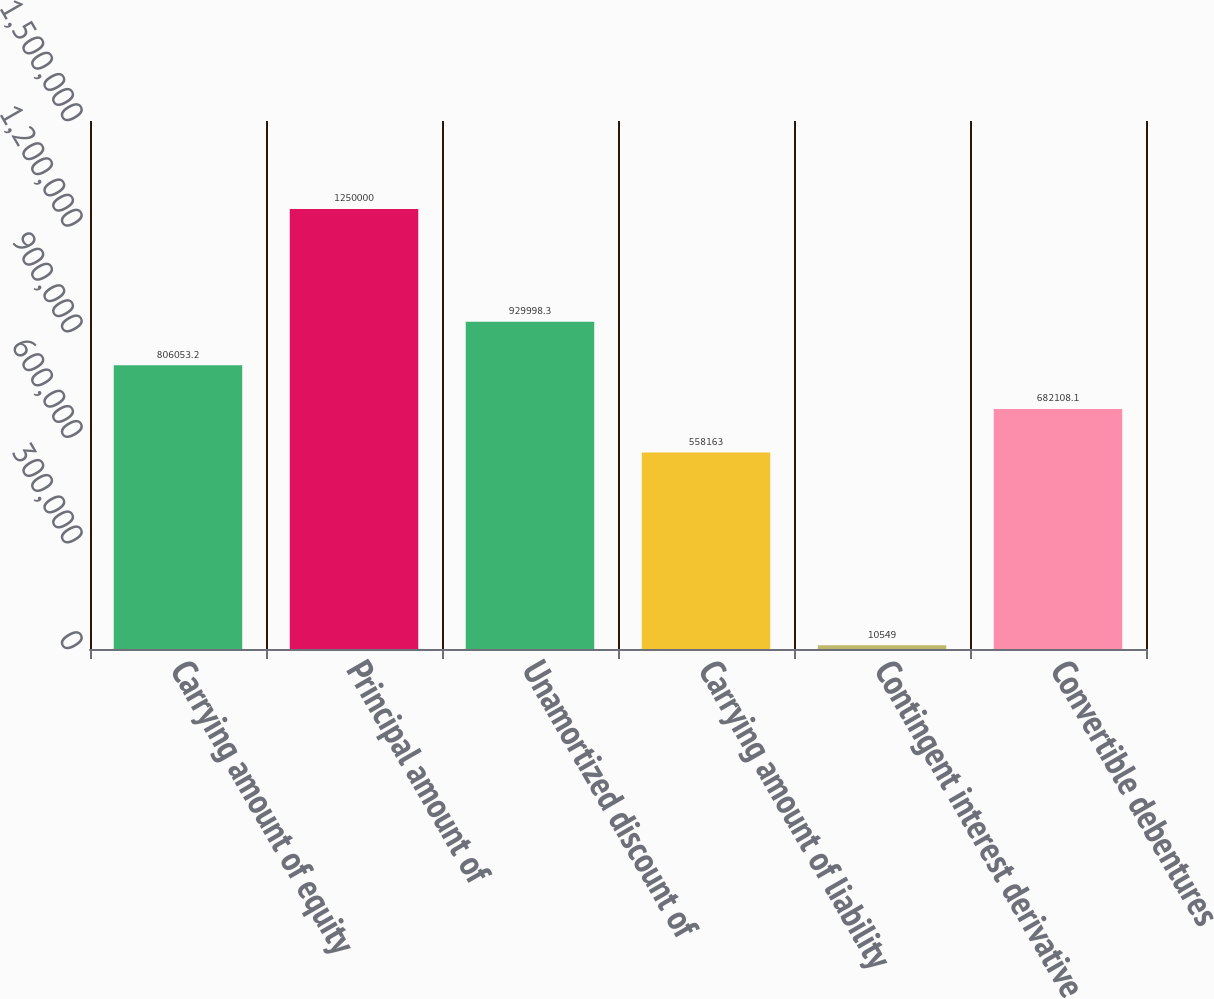<chart> <loc_0><loc_0><loc_500><loc_500><bar_chart><fcel>Carrying amount of equity<fcel>Principal amount of<fcel>Unamortized discount of<fcel>Carrying amount of liability<fcel>Contingent interest derivative<fcel>Convertible debentures<nl><fcel>806053<fcel>1.25e+06<fcel>929998<fcel>558163<fcel>10549<fcel>682108<nl></chart> 